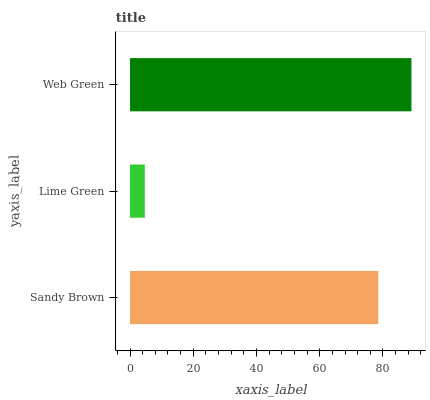Is Lime Green the minimum?
Answer yes or no. Yes. Is Web Green the maximum?
Answer yes or no. Yes. Is Web Green the minimum?
Answer yes or no. No. Is Lime Green the maximum?
Answer yes or no. No. Is Web Green greater than Lime Green?
Answer yes or no. Yes. Is Lime Green less than Web Green?
Answer yes or no. Yes. Is Lime Green greater than Web Green?
Answer yes or no. No. Is Web Green less than Lime Green?
Answer yes or no. No. Is Sandy Brown the high median?
Answer yes or no. Yes. Is Sandy Brown the low median?
Answer yes or no. Yes. Is Lime Green the high median?
Answer yes or no. No. Is Web Green the low median?
Answer yes or no. No. 